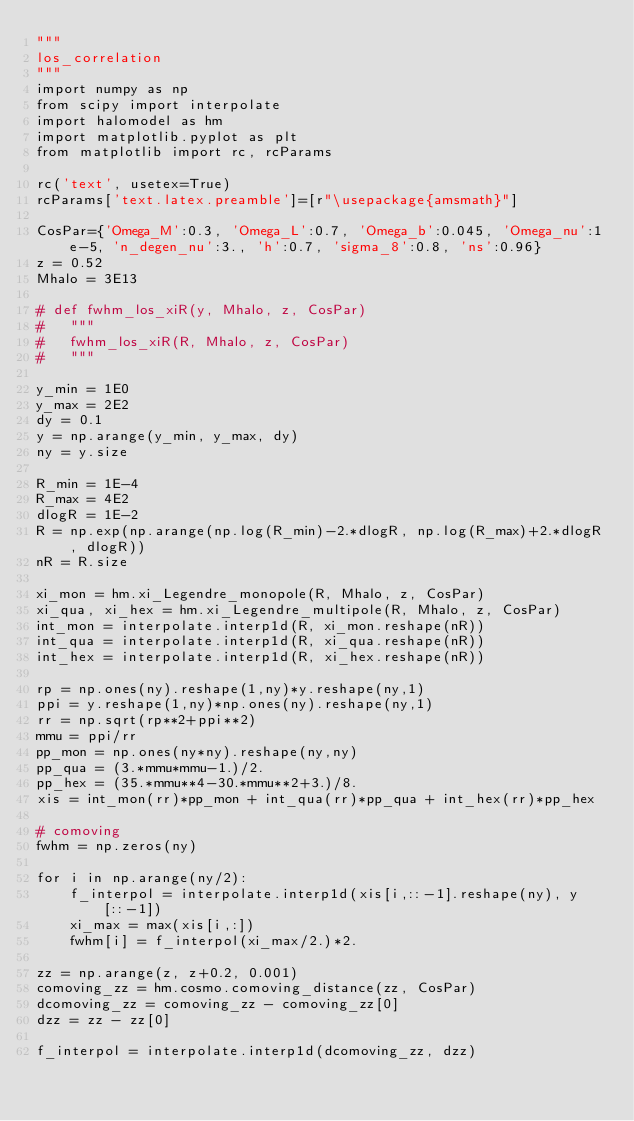<code> <loc_0><loc_0><loc_500><loc_500><_Python_>"""
los_correlation
"""
import numpy as np
from scipy import interpolate
import halomodel as hm
import matplotlib.pyplot as plt
from matplotlib import rc, rcParams

rc('text', usetex=True)
rcParams['text.latex.preamble']=[r"\usepackage{amsmath}"]

CosPar={'Omega_M':0.3, 'Omega_L':0.7, 'Omega_b':0.045, 'Omega_nu':1e-5, 'n_degen_nu':3., 'h':0.7, 'sigma_8':0.8, 'ns':0.96}
z = 0.52
Mhalo = 3E13

# def fwhm_los_xiR(y, Mhalo, z, CosPar)
#   """
#   fwhm_los_xiR(R, Mhalo, z, CosPar)
#   """

y_min = 1E0
y_max = 2E2
dy = 0.1
y = np.arange(y_min, y_max, dy)
ny = y.size

R_min = 1E-4
R_max = 4E2
dlogR = 1E-2
R = np.exp(np.arange(np.log(R_min)-2.*dlogR, np.log(R_max)+2.*dlogR, dlogR))
nR = R.size

xi_mon = hm.xi_Legendre_monopole(R, Mhalo, z, CosPar)
xi_qua, xi_hex = hm.xi_Legendre_multipole(R, Mhalo, z, CosPar)
int_mon = interpolate.interp1d(R, xi_mon.reshape(nR))
int_qua = interpolate.interp1d(R, xi_qua.reshape(nR))
int_hex = interpolate.interp1d(R, xi_hex.reshape(nR))

rp = np.ones(ny).reshape(1,ny)*y.reshape(ny,1)
ppi = y.reshape(1,ny)*np.ones(ny).reshape(ny,1)
rr = np.sqrt(rp**2+ppi**2)
mmu = ppi/rr
pp_mon = np.ones(ny*ny).reshape(ny,ny)
pp_qua = (3.*mmu*mmu-1.)/2.
pp_hex = (35.*mmu**4-30.*mmu**2+3.)/8.
xis = int_mon(rr)*pp_mon + int_qua(rr)*pp_qua + int_hex(rr)*pp_hex

# comoving
fwhm = np.zeros(ny)

for i in np.arange(ny/2):
    f_interpol = interpolate.interp1d(xis[i,::-1].reshape(ny), y[::-1])
    xi_max = max(xis[i,:])
    fwhm[i] = f_interpol(xi_max/2.)*2.

zz = np.arange(z, z+0.2, 0.001)
comoving_zz = hm.cosmo.comoving_distance(zz, CosPar)
dcomoving_zz = comoving_zz - comoving_zz[0]
dzz = zz - zz[0]

f_interpol = interpolate.interp1d(dcomoving_zz, dzz)</code> 